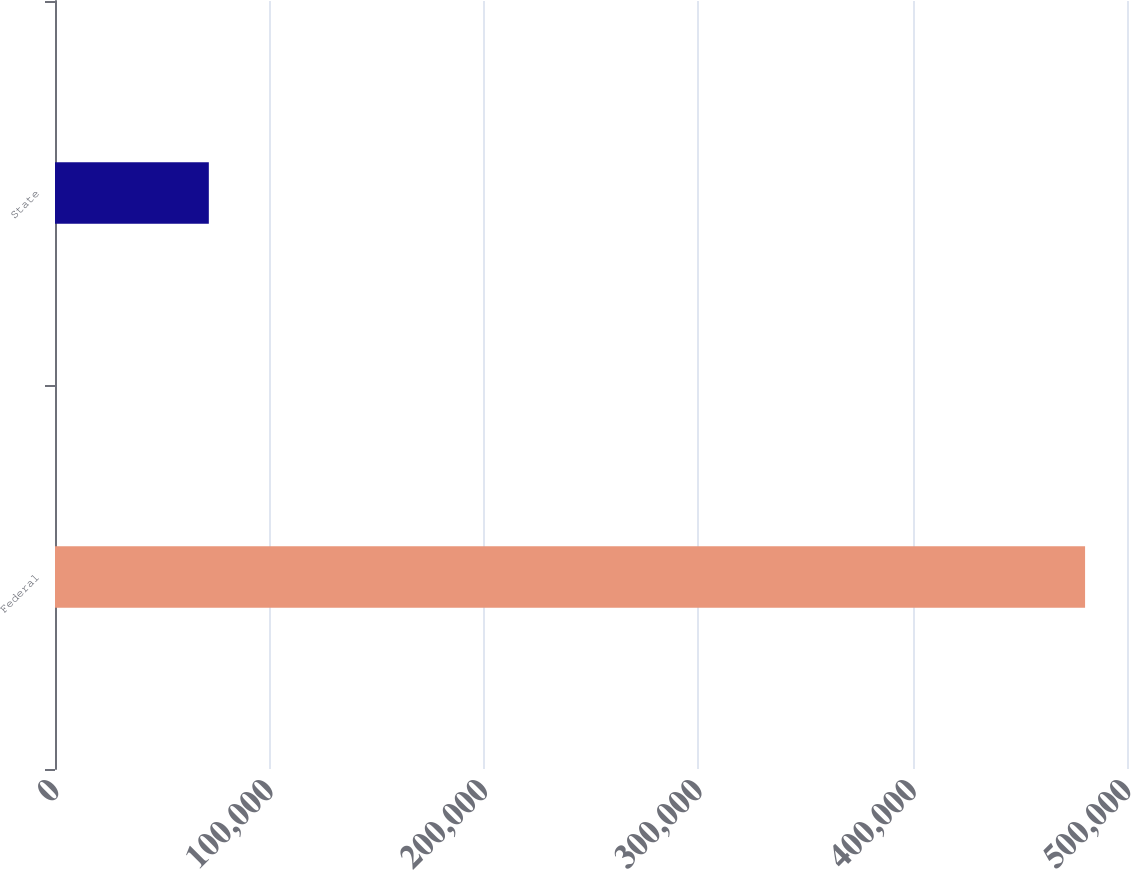Convert chart to OTSL. <chart><loc_0><loc_0><loc_500><loc_500><bar_chart><fcel>Federal<fcel>State<nl><fcel>480446<fcel>71750<nl></chart> 